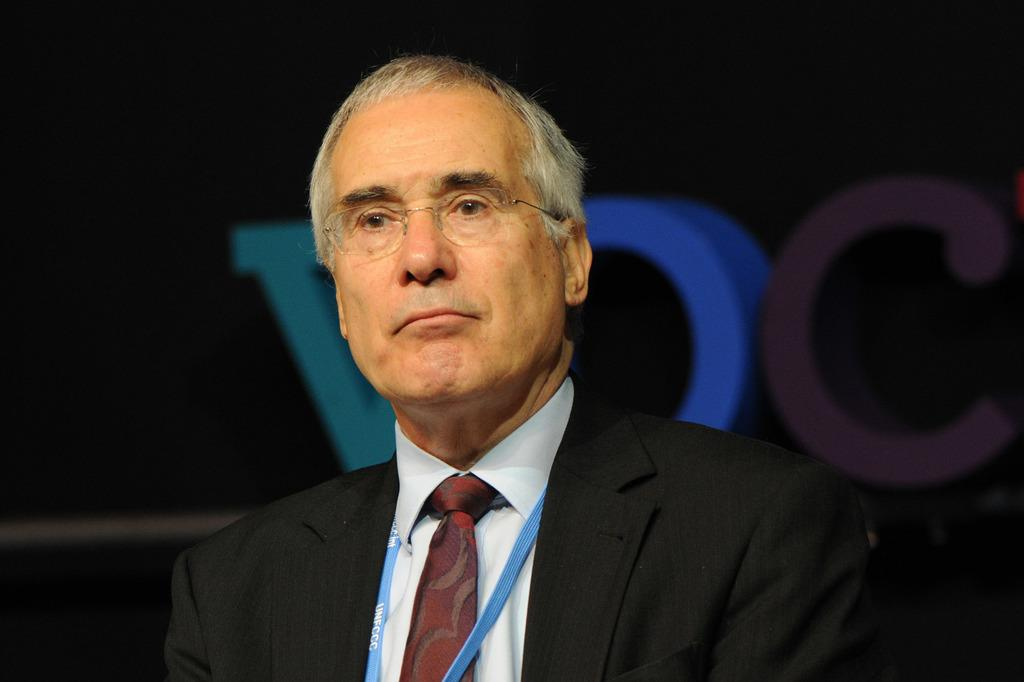Who is the main subject in the image? There is an old man in the image. What is the old man wearing? The old man is wearing spectacles and a black coat. What is the old man doing in the image? The old man is looking at someone. What type of text is present in the image? There is colored text on a black background in the image. What type of box is being kicked in the image? There is no box or kicking action present in the image. 